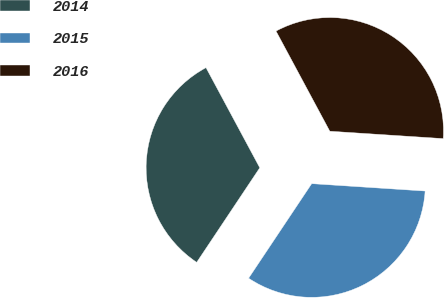<chart> <loc_0><loc_0><loc_500><loc_500><pie_chart><fcel>2014<fcel>2015<fcel>2016<nl><fcel>32.79%<fcel>33.33%<fcel>33.88%<nl></chart> 